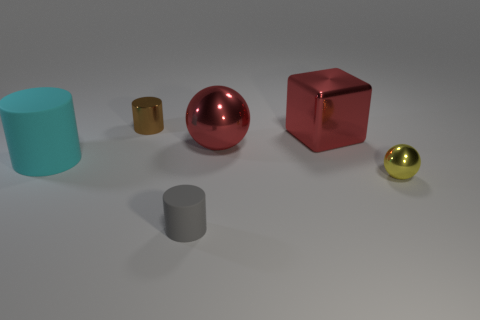What number of yellow shiny objects have the same shape as the gray thing?
Provide a succinct answer. 0. Is the big shiny cube the same color as the small ball?
Give a very brief answer. No. Is there any other thing that has the same shape as the small brown metallic thing?
Your answer should be very brief. Yes. Are there any other blocks that have the same color as the cube?
Your response must be concise. No. Are the big thing that is on the left side of the small rubber thing and the small cylinder that is on the right side of the tiny shiny cylinder made of the same material?
Make the answer very short. Yes. The small shiny cylinder is what color?
Your answer should be very brief. Brown. There is a object that is on the left side of the tiny thing that is on the left side of the cylinder that is in front of the tiny yellow sphere; what size is it?
Ensure brevity in your answer.  Large. What number of other things are there of the same size as the yellow metal ball?
Provide a short and direct response. 2. How many red objects are made of the same material as the red block?
Your answer should be compact. 1. What is the shape of the gray thing that is on the right side of the cyan rubber object?
Your answer should be very brief. Cylinder. 